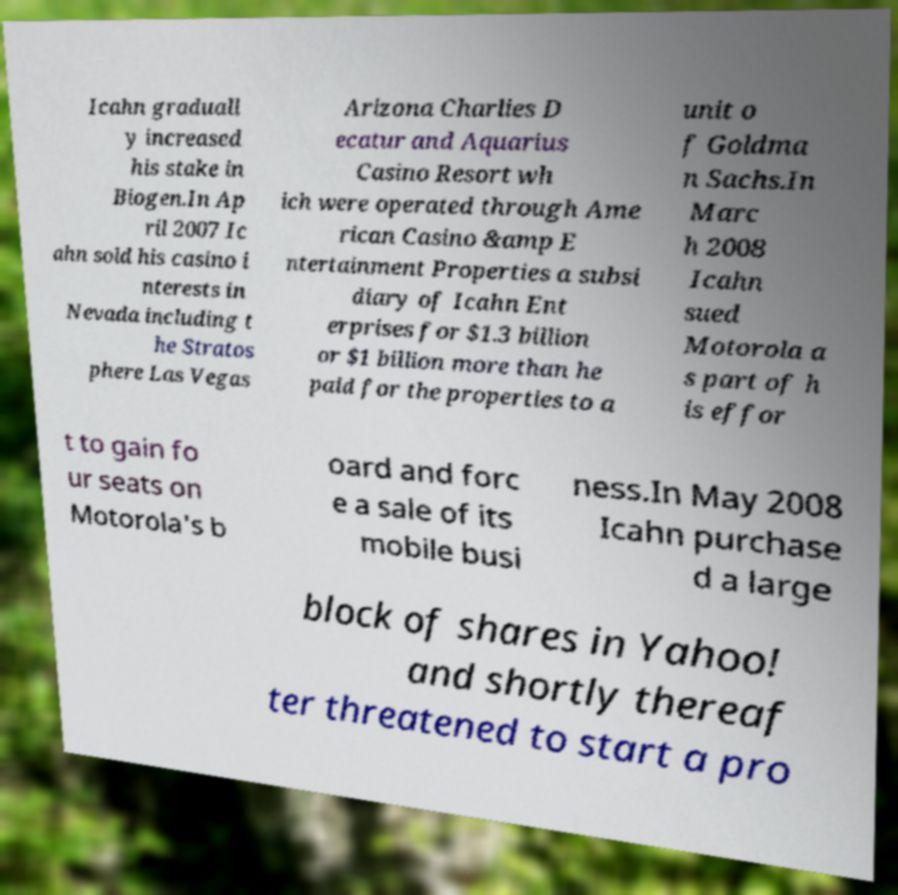Could you assist in decoding the text presented in this image and type it out clearly? Icahn graduall y increased his stake in Biogen.In Ap ril 2007 Ic ahn sold his casino i nterests in Nevada including t he Stratos phere Las Vegas Arizona Charlies D ecatur and Aquarius Casino Resort wh ich were operated through Ame rican Casino &amp E ntertainment Properties a subsi diary of Icahn Ent erprises for $1.3 billion or $1 billion more than he paid for the properties to a unit o f Goldma n Sachs.In Marc h 2008 Icahn sued Motorola a s part of h is effor t to gain fo ur seats on Motorola's b oard and forc e a sale of its mobile busi ness.In May 2008 Icahn purchase d a large block of shares in Yahoo! and shortly thereaf ter threatened to start a pro 